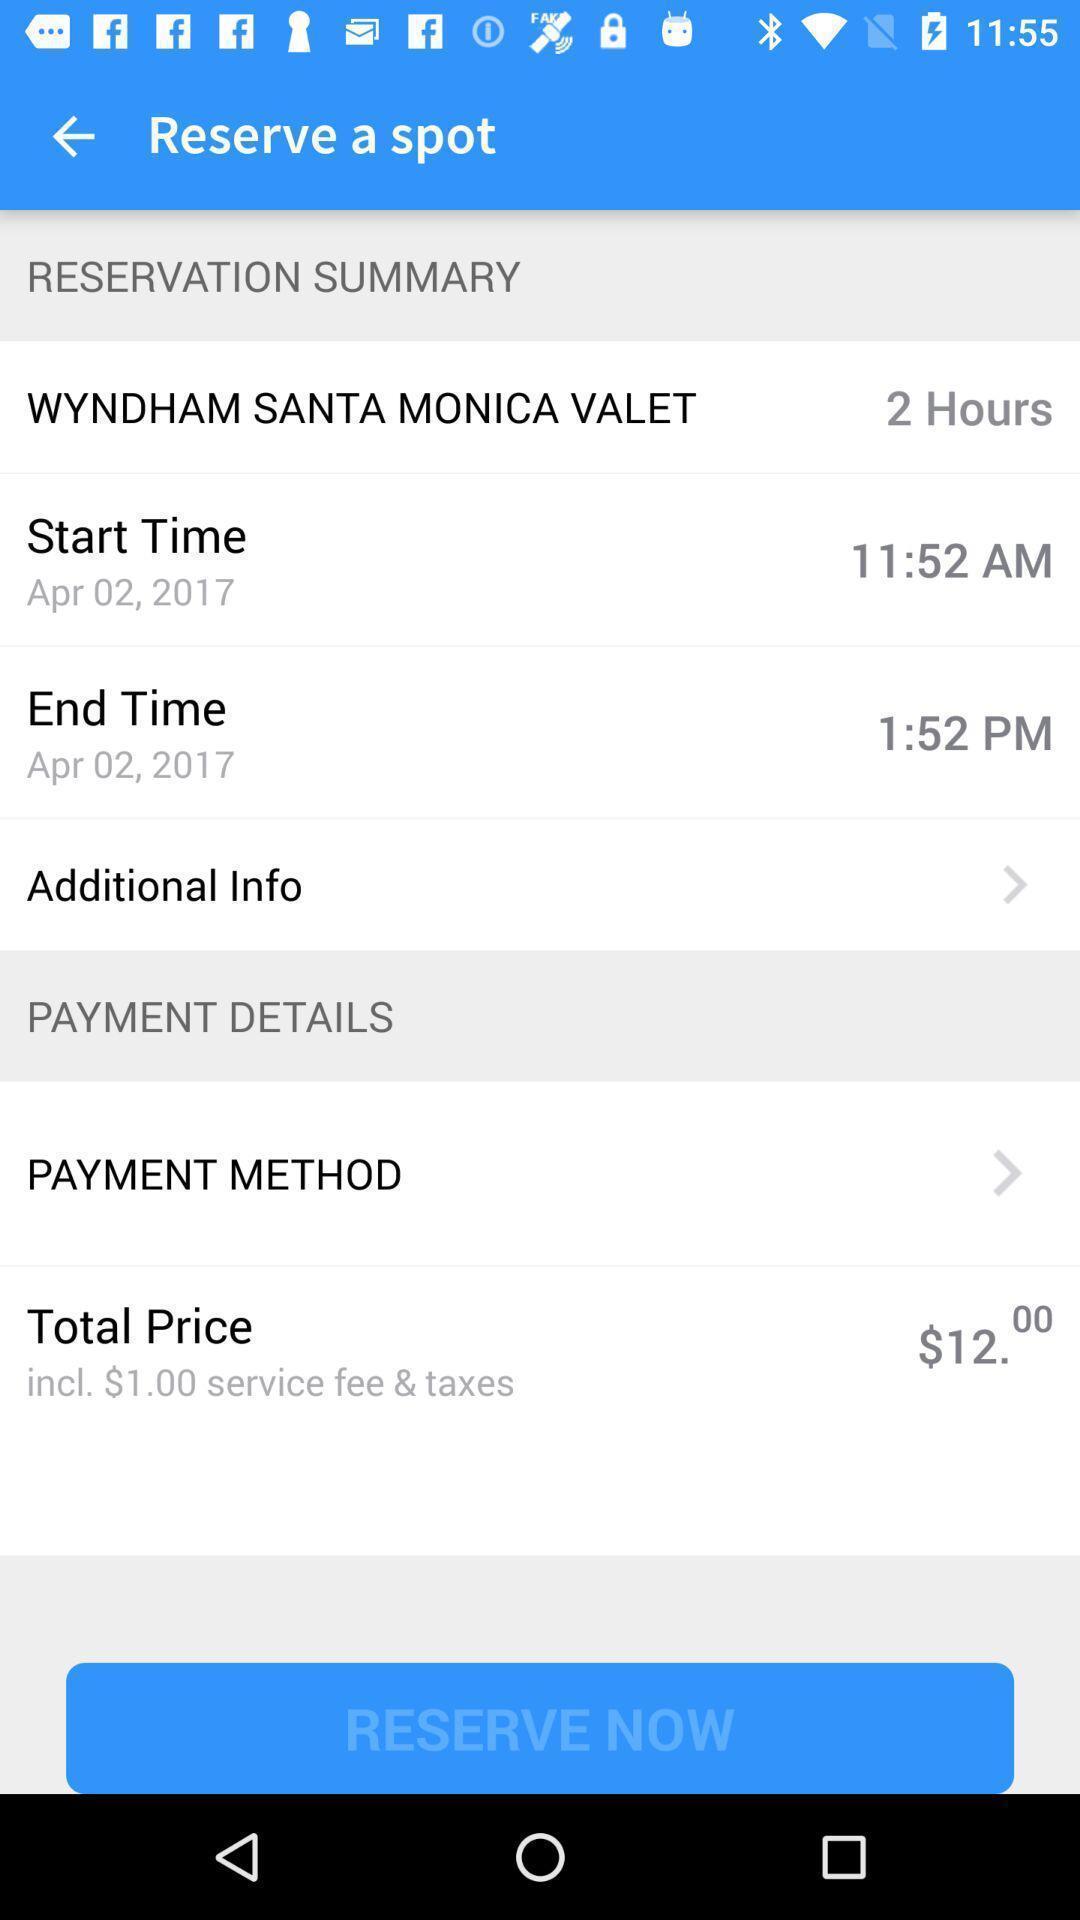Provide a textual representation of this image. Screen displaying the reservation summary. 